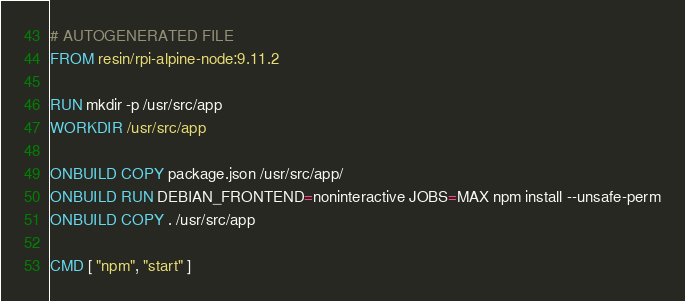<code> <loc_0><loc_0><loc_500><loc_500><_Dockerfile_># AUTOGENERATED FILE
FROM resin/rpi-alpine-node:9.11.2

RUN mkdir -p /usr/src/app
WORKDIR /usr/src/app

ONBUILD COPY package.json /usr/src/app/
ONBUILD RUN DEBIAN_FRONTEND=noninteractive JOBS=MAX npm install --unsafe-perm
ONBUILD COPY . /usr/src/app

CMD [ "npm", "start" ]
</code> 